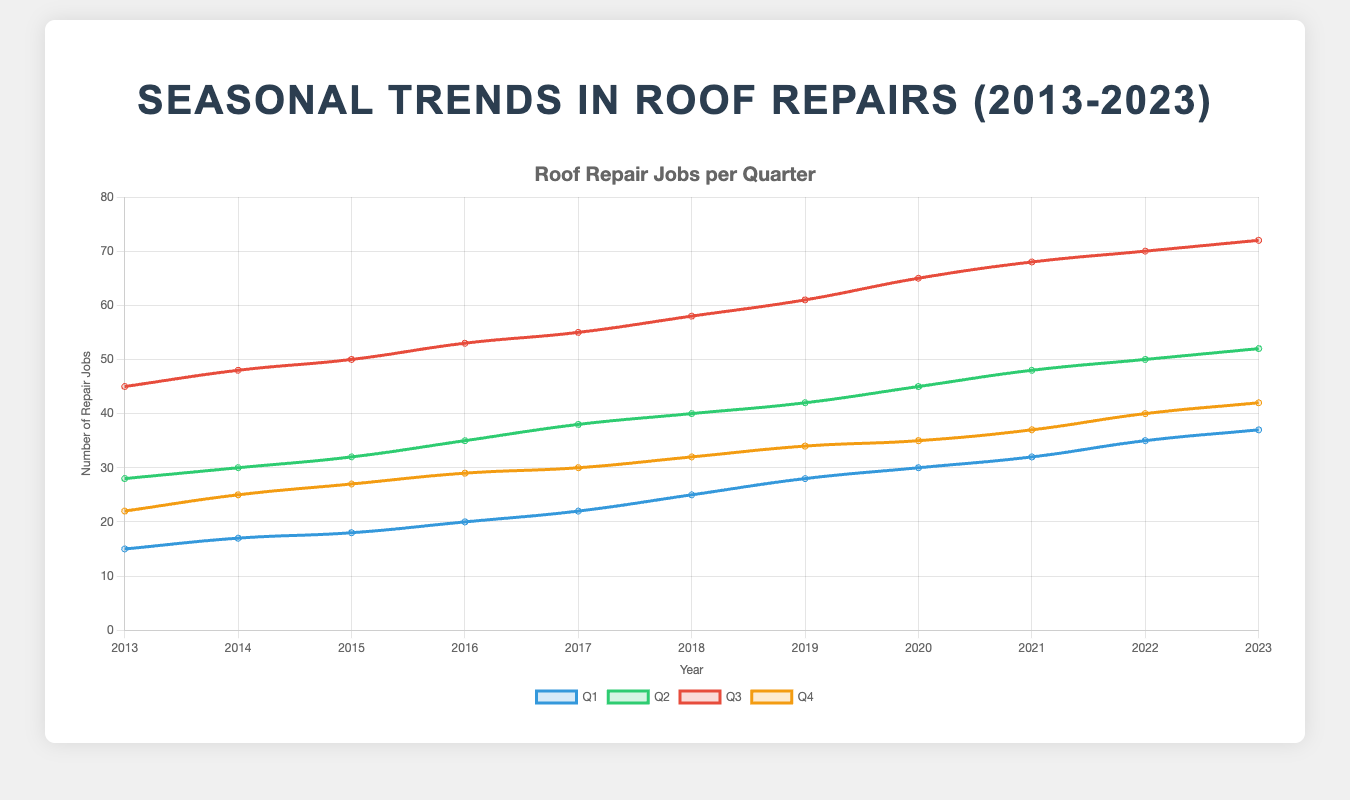What is the trend of roof repair jobs in Q3 from 2013 to 2023? To see the trend, look at the line for Q3 across all years. The line rises consistently, indicating an increasing trend in the number of roof repair jobs during Q3 from 2013 to 2023. In 2013, the number of jobs was 45 and increased to 72 by 2023.
Answer: Increasing Which quarter had the highest number of repairs in 2023? To determine this, compare the values of all quarters for the year 2023. The values are Q1: 37, Q2: 52, Q3: 72, Q4: 42. Q3 has the highest value of 72 repairs.
Answer: Q3 By how much did the number of roof repairs in Q1 increase from 2013 to 2023? Compare the Q1 values for 2013 and 2023. In 2013, it was 15, and in 2023, it was 37. The increase is calculated as 37 - 15 = 22.
Answer: 22 Which year saw the biggest increase in the number of Q2 roof repairs compared to the previous year? Calculate the year-on-year differences for Q2, and find the maximum value. 
2014-2013: 30 - 28 = 2, 
2015-2014: 32 - 30 = 2, 
2016-2015: 35 - 32 = 3, 
2017-2016: 38 - 35 = 3, 
2018-2017: 40 - 38 = 2, 
2019-2018: 42 - 40 = 2, 
2020-2019: 45 - 42 = 3, 
2021-2020: 48 - 45 = 3, 
2022-2021: 50 - 48 = 2,
2023-2022: 52 - 50 = 2. 
The biggest increase is 3, observed in the years 2016, 2017, 2020, and 2021.
Answer: 2016, 2017, 2020, and 2021 What is the average number of repairs for Q4 over the last decade? To find the average, add the values for Q4 from 2013 to 2023 and divide by the number of years. 
The values are 22, 25, 27, 29, 30, 32, 34, 35, 37, 40, 42. 
Sum is 22 + 25 + 27 + 29 + 30 + 32 + 34 + 35 + 37 + 40 + 42 = 353. 
The number of years is 11, so the average is 353 / 11 ≈ 32.09.
Answer: 32.09 What is the total number of roof repairs for Q2 across all years? Sum the values of Q2 for each year. The values are 28, 30, 32, 35, 38, 40, 42, 45, 48, 50, 52. 
The sum is 28 + 30 + 32 + 35 + 38 + 40 + 42 + 45 + 48 + 50 + 52 = 440.
Answer: 440 Compare the growth rate of Q1 and Q3 from 2013 to 2023. Which quarter grew faster? Calculate the growth rate for Q1 and Q3. For Q1: (37 - 15) / 15 = 1.47 or 147%. For Q3: (72 - 45) / 45 = 0.6 or 60%. Q1 grew 147%, and Q3 grew 60%. Q1 grew faster.
Answer: Q1 Which quarter consistently had fewer repairs each year compared to Q3? Compare each quarter's values directly with Q3 for every year from 2013 to 2023. 
Q1 values (15, 17, 18, 20, 22, 25, 28, 30, 32, 35, 37) are consistently lower than Q3 in all years.
Answer: Q1 